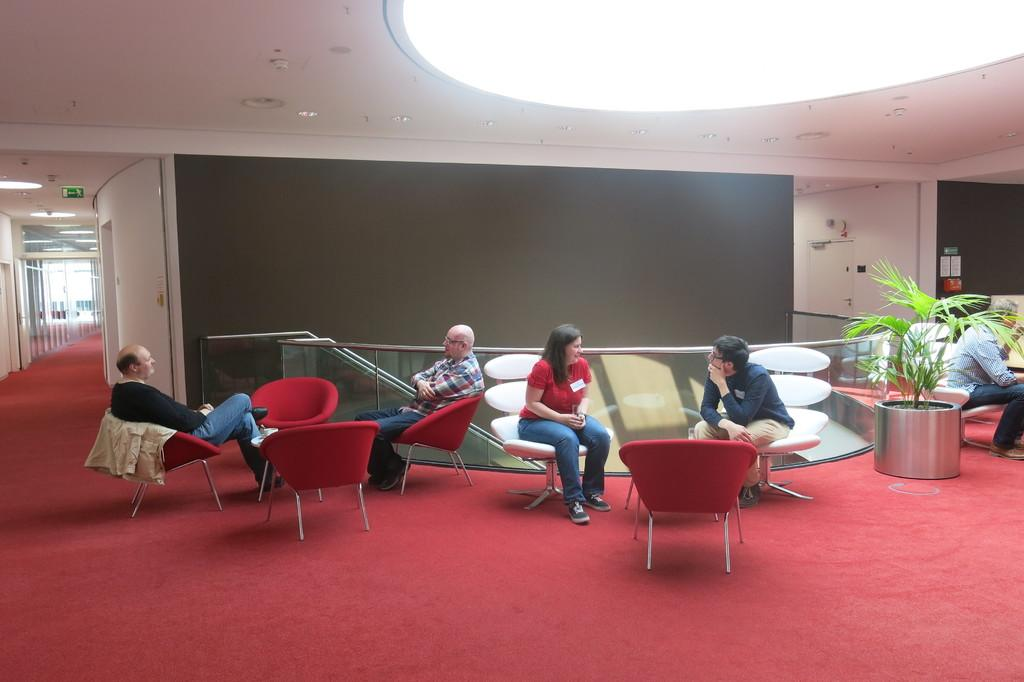What is located above the persons sitting on chairs in the image? There is a ceiling and light in the image. What can be used to indicate the location of an exit in the image? There is an exit board in the image. What type of flooring is present in the image? There is a red carpet on the floor. What type of vegetation is present in the image? There is a plant in the image. What are the persons sitting on in the image? There are persons sitting on chairs in the image. What architectural feature is present in the image? There is a door in the image. What type of toy can be seen being used by the coach in the image? There is no coach or toy present in the image. How does the downtown area look in the image? There is no downtown area present in the image. 